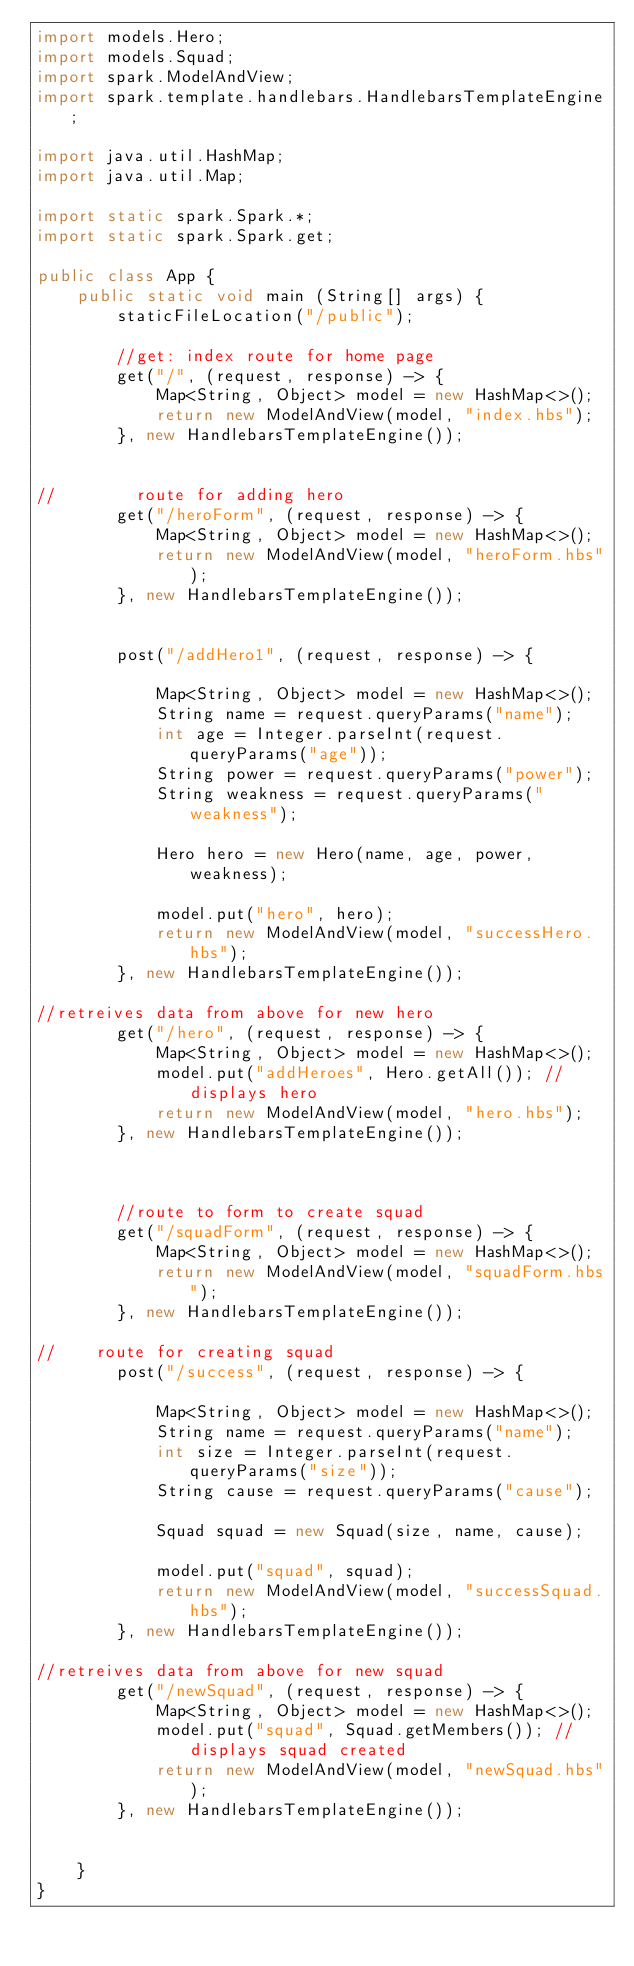Convert code to text. <code><loc_0><loc_0><loc_500><loc_500><_Java_>import models.Hero;
import models.Squad;
import spark.ModelAndView;
import spark.template.handlebars.HandlebarsTemplateEngine;

import java.util.HashMap;
import java.util.Map;

import static spark.Spark.*;
import static spark.Spark.get;

public class App {
    public static void main (String[] args) {
        staticFileLocation("/public");

        //get: index route for home page
        get("/", (request, response) -> {
            Map<String, Object> model = new HashMap<>();
            return new ModelAndView(model, "index.hbs");
        }, new HandlebarsTemplateEngine());


//        route for adding hero
        get("/heroForm", (request, response) -> {
            Map<String, Object> model = new HashMap<>();
            return new ModelAndView(model, "heroForm.hbs");
        }, new HandlebarsTemplateEngine());


        post("/addHero1", (request, response) -> {

            Map<String, Object> model = new HashMap<>();
            String name = request.queryParams("name");
            int age = Integer.parseInt(request.queryParams("age"));
            String power = request.queryParams("power");
            String weakness = request.queryParams("weakness");

            Hero hero = new Hero(name, age, power, weakness);

            model.put("hero", hero);
            return new ModelAndView(model, "successHero.hbs");
        }, new HandlebarsTemplateEngine());

//retreives data from above for new hero
        get("/hero", (request, response) -> {
            Map<String, Object> model = new HashMap<>();
            model.put("addHeroes", Hero.getAll()); //displays hero
            return new ModelAndView(model, "hero.hbs");
        }, new HandlebarsTemplateEngine());



        //route to form to create squad
        get("/squadForm", (request, response) -> {
            Map<String, Object> model = new HashMap<>();
            return new ModelAndView(model, "squadForm.hbs");
        }, new HandlebarsTemplateEngine());

//    route for creating squad
        post("/success", (request, response) -> {

            Map<String, Object> model = new HashMap<>();
            String name = request.queryParams("name");
            int size = Integer.parseInt(request.queryParams("size"));
            String cause = request.queryParams("cause");

            Squad squad = new Squad(size, name, cause);

            model.put("squad", squad);
            return new ModelAndView(model, "successSquad.hbs");
        }, new HandlebarsTemplateEngine());

//retreives data from above for new squad
        get("/newSquad", (request, response) -> {
            Map<String, Object> model = new HashMap<>();
            model.put("squad", Squad.getMembers()); //displays squad created
            return new ModelAndView(model, "newSquad.hbs");
        }, new HandlebarsTemplateEngine());


    }
}


</code> 